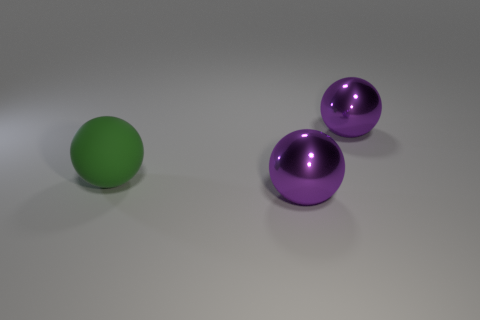Can you tell me the colors of the objects in the image? There are three objects in the image: one is green and the other two are purple. 